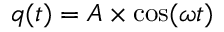<formula> <loc_0><loc_0><loc_500><loc_500>q ( t ) = A \times \cos ( \omega t )</formula> 